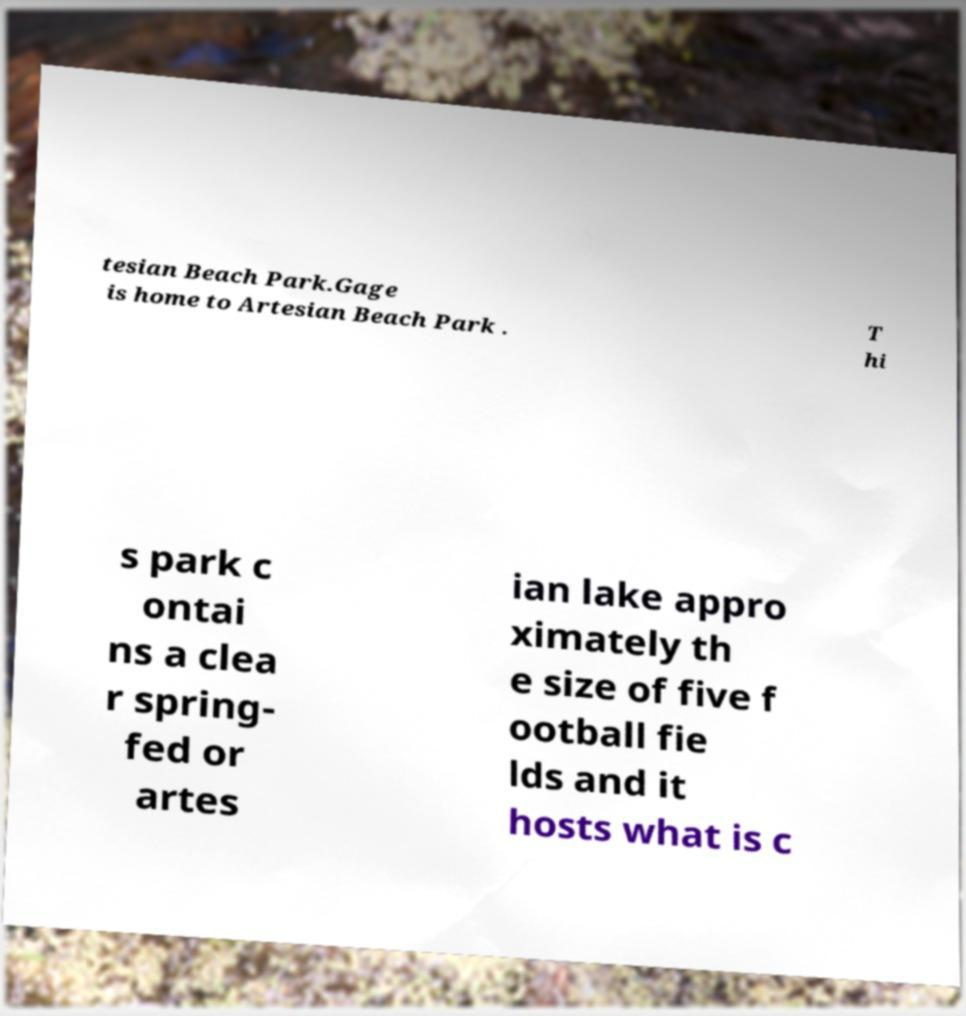Could you extract and type out the text from this image? tesian Beach Park.Gage is home to Artesian Beach Park . T hi s park c ontai ns a clea r spring- fed or artes ian lake appro ximately th e size of five f ootball fie lds and it hosts what is c 